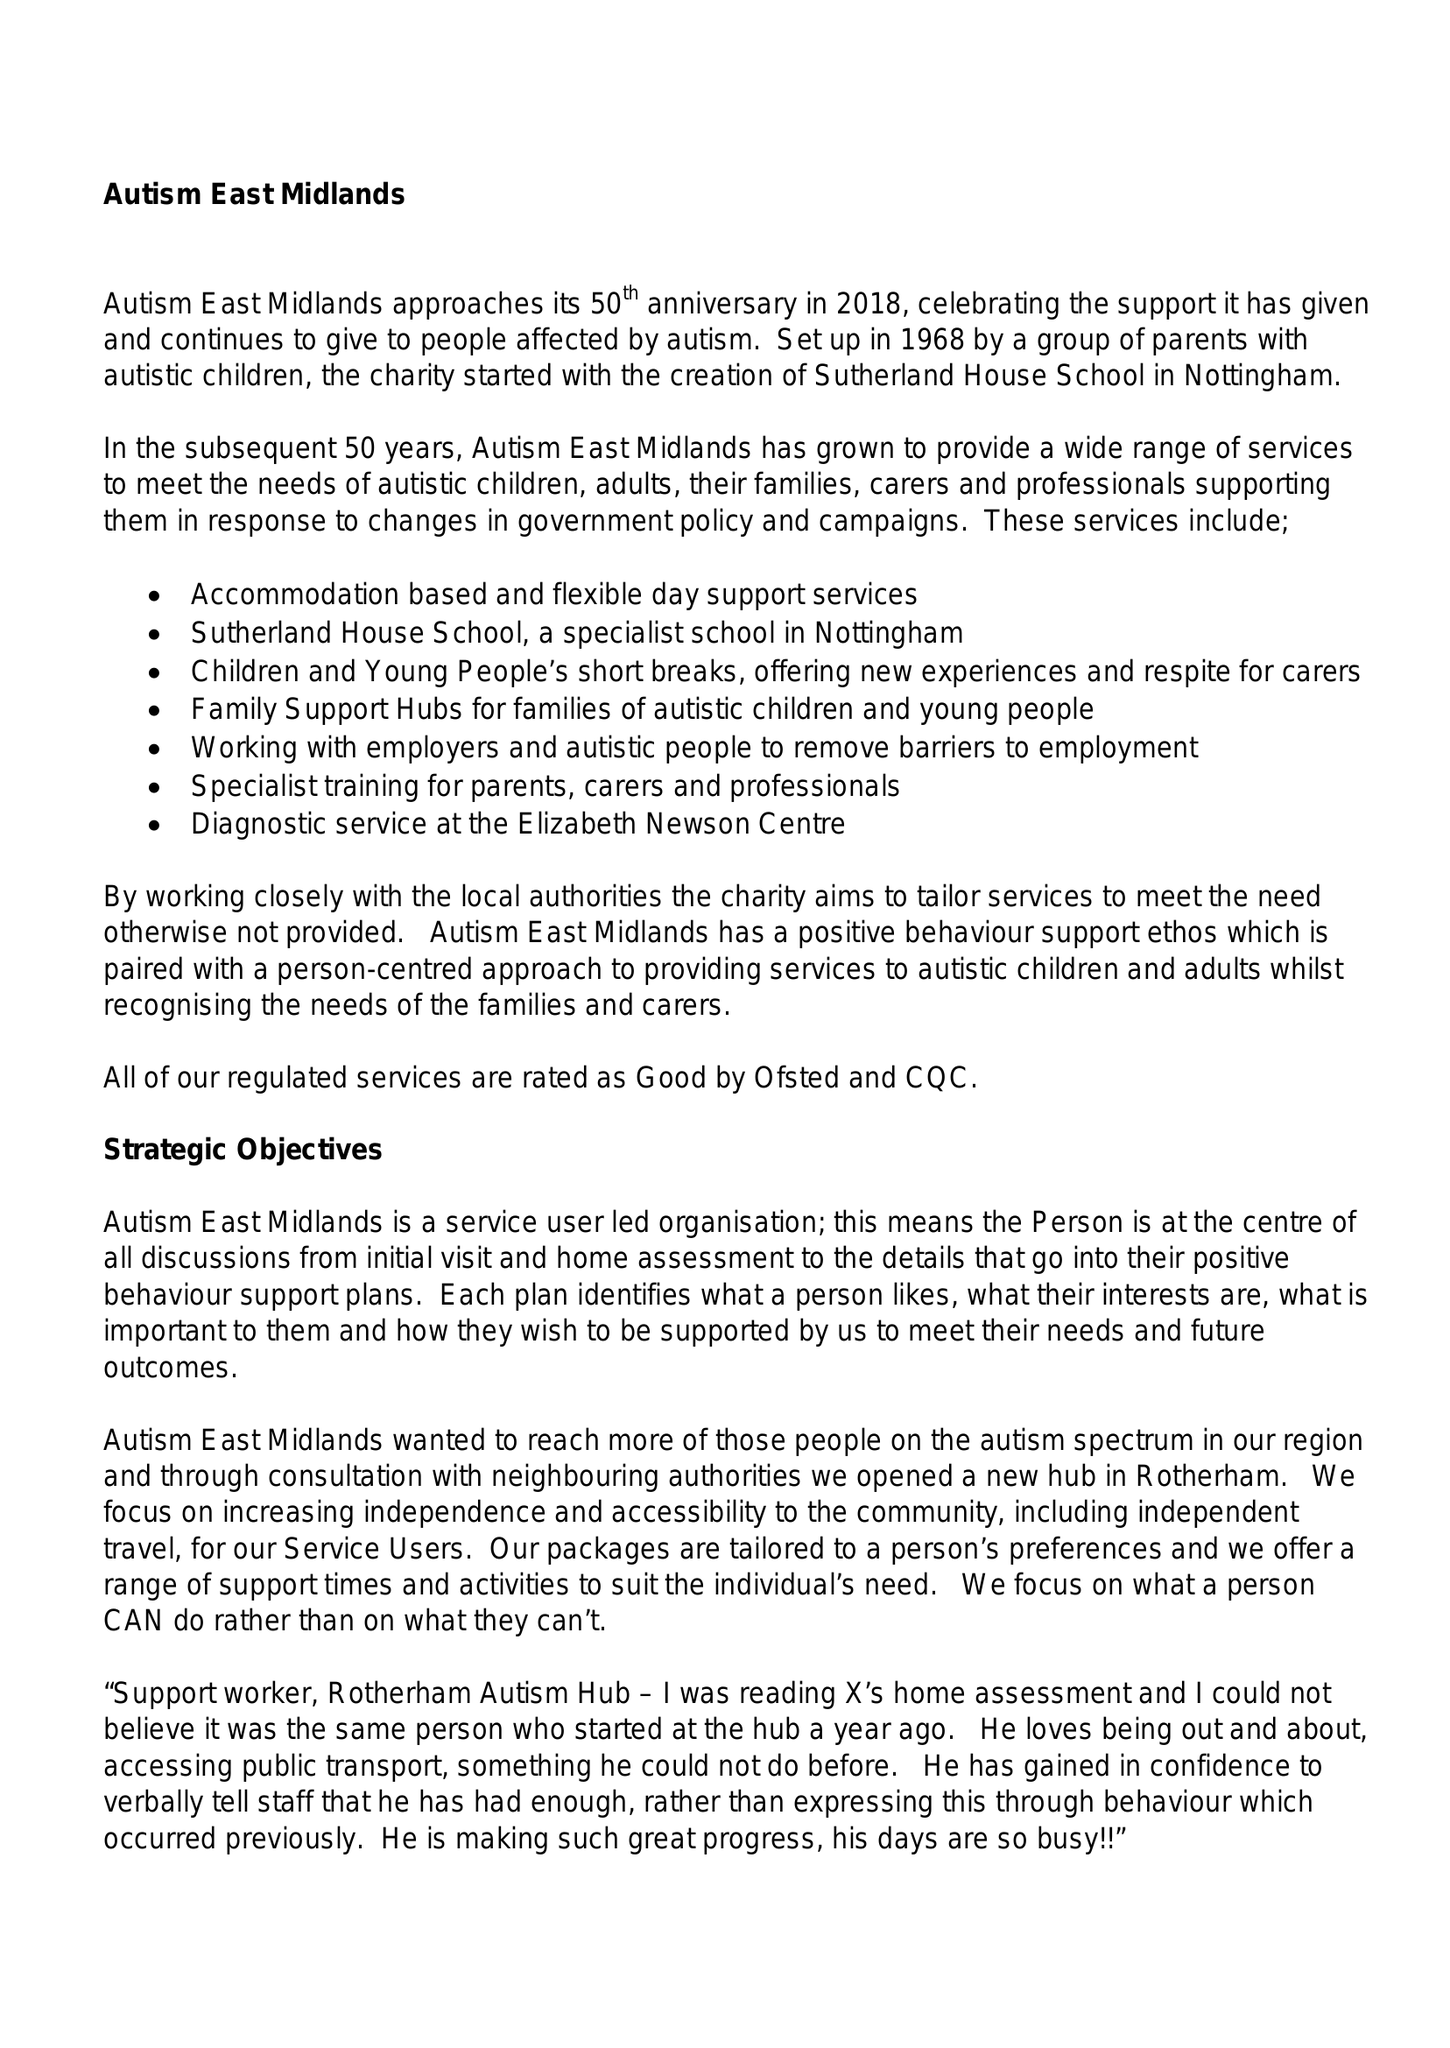What is the value for the address__street_line?
Answer the question using a single word or phrase. MORVEN STREET 